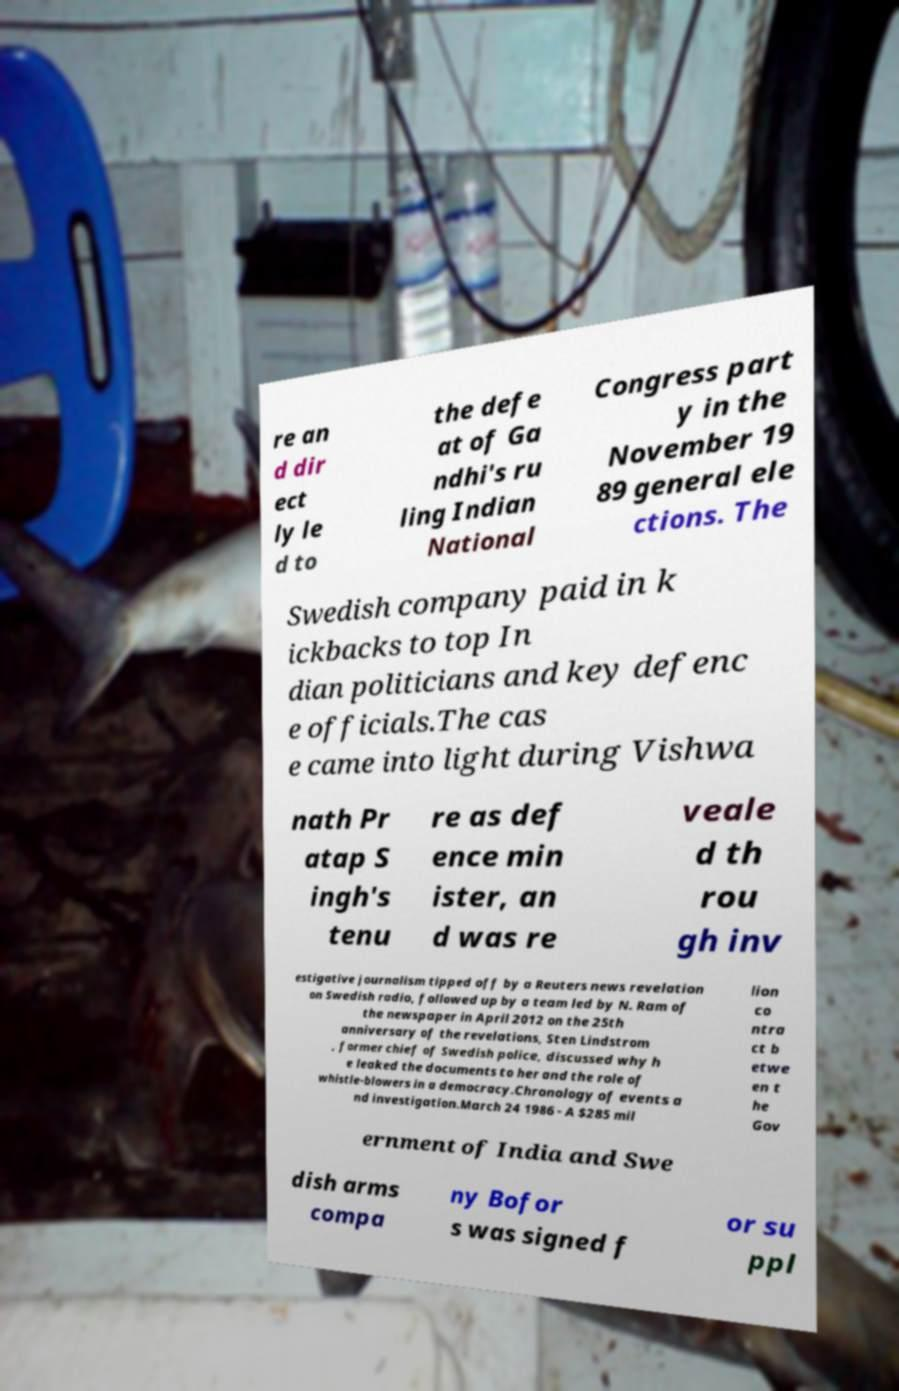Could you extract and type out the text from this image? re an d dir ect ly le d to the defe at of Ga ndhi's ru ling Indian National Congress part y in the November 19 89 general ele ctions. The Swedish company paid in k ickbacks to top In dian politicians and key defenc e officials.The cas e came into light during Vishwa nath Pr atap S ingh's tenu re as def ence min ister, an d was re veale d th rou gh inv estigative journalism tipped off by a Reuters news revelation on Swedish radio, followed up by a team led by N. Ram of the newspaper in April 2012 on the 25th anniversary of the revelations, Sten Lindstrom , former chief of Swedish police, discussed why h e leaked the documents to her and the role of whistle-blowers in a democracy.Chronology of events a nd investigation.March 24 1986 - A $285 mil lion co ntra ct b etwe en t he Gov ernment of India and Swe dish arms compa ny Bofor s was signed f or su ppl 